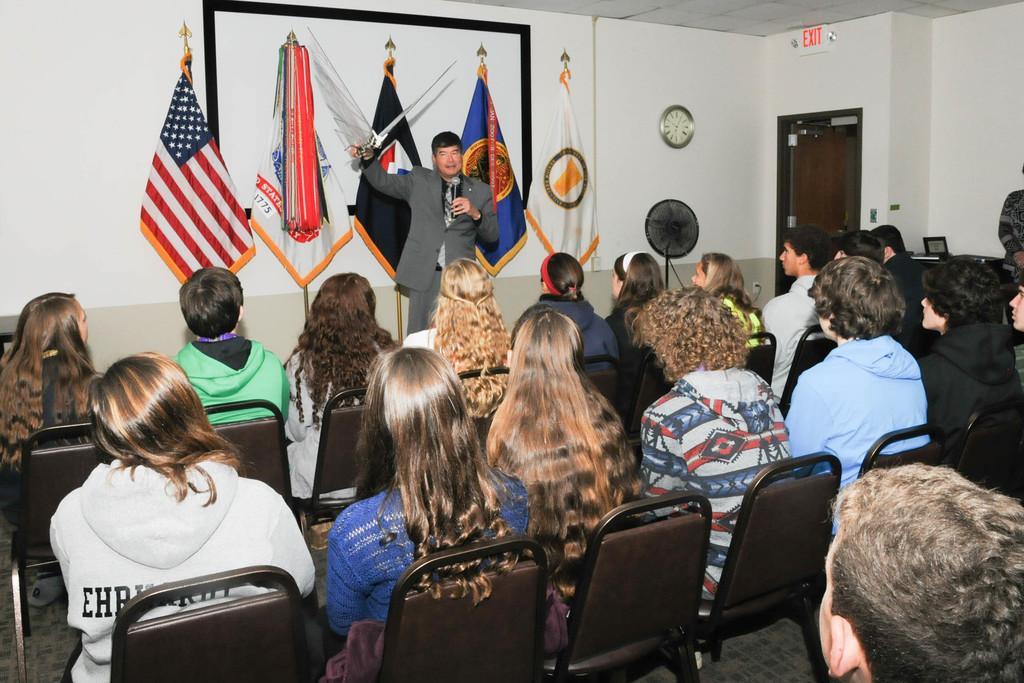Describe this image in one or two sentences. In this picture I can see group of people sitting on the chairs, there is a person standing and holding a sword and a mike, there is a table fan, there is a board and a clock attached to the wall, flags with the poles, there is a door and some other items. 